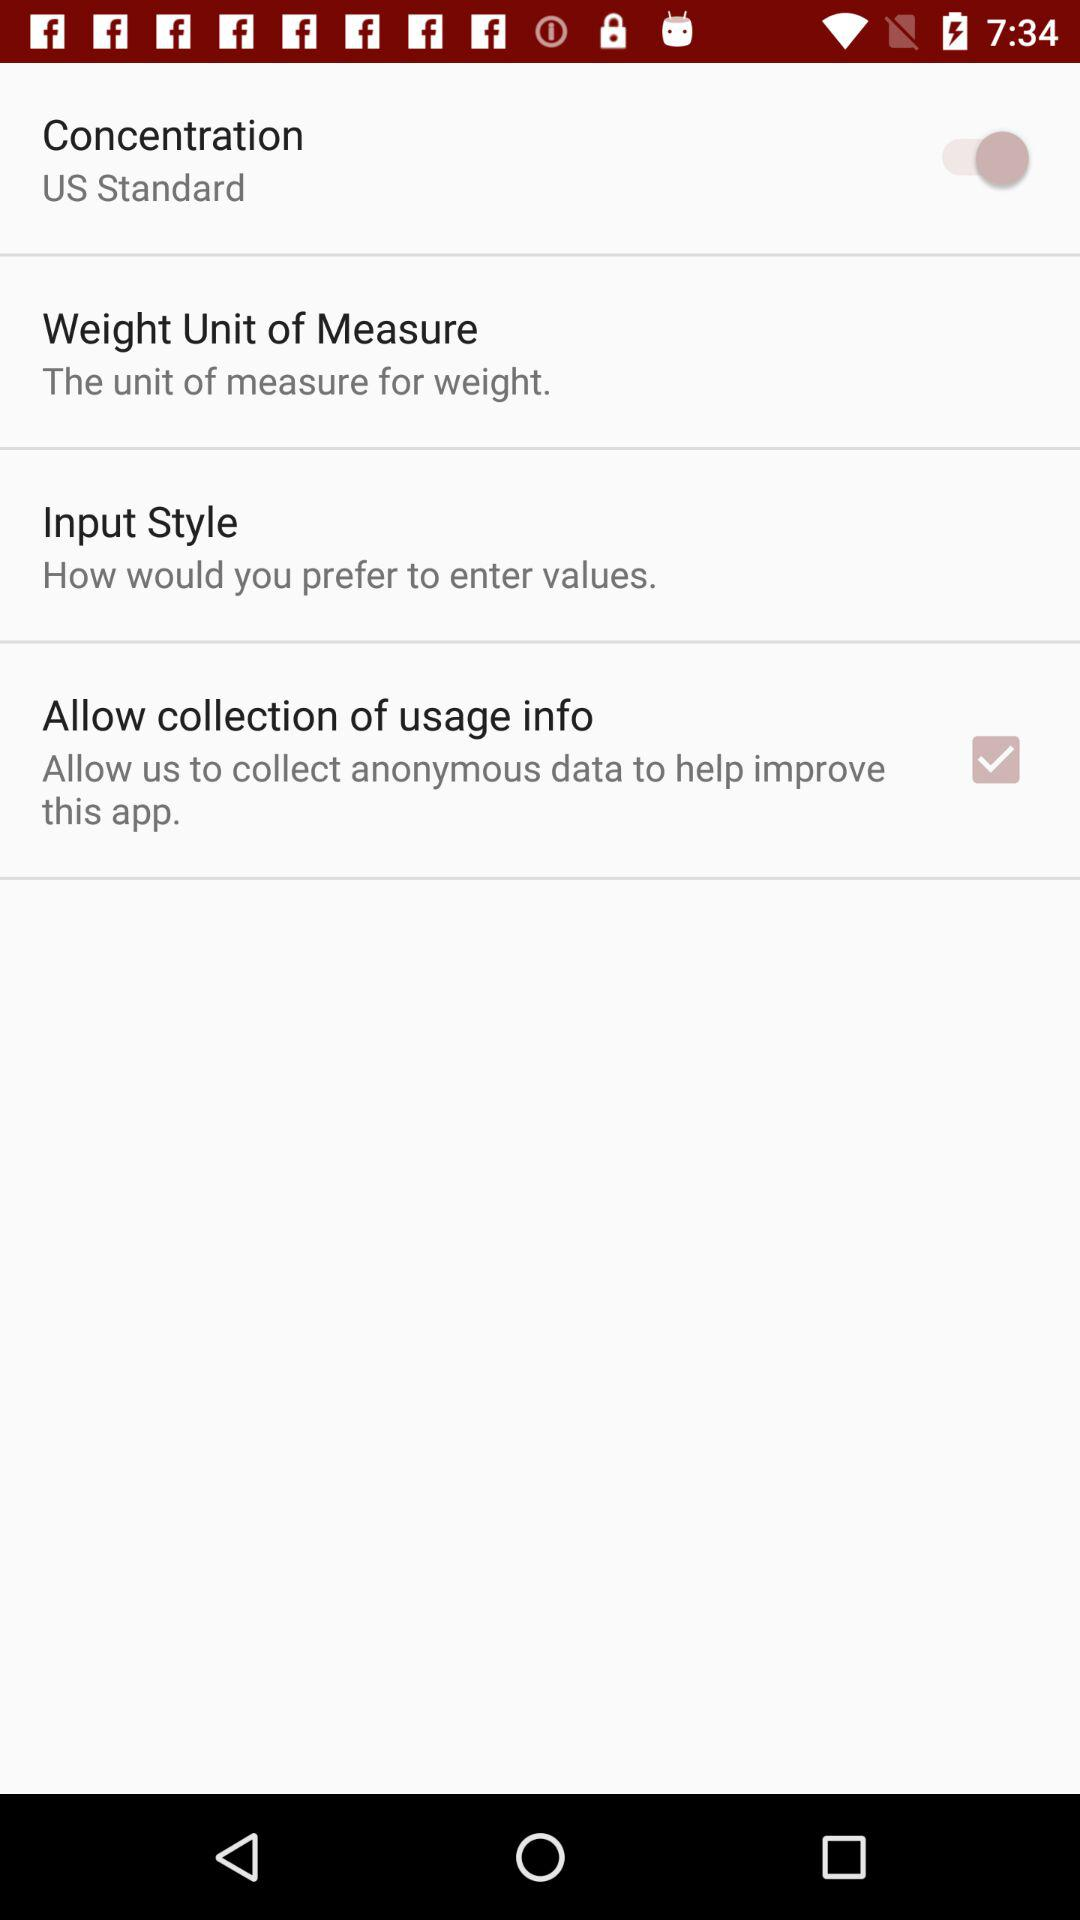What is the selected weight unit?
When the provided information is insufficient, respond with <no answer>. <no answer> 